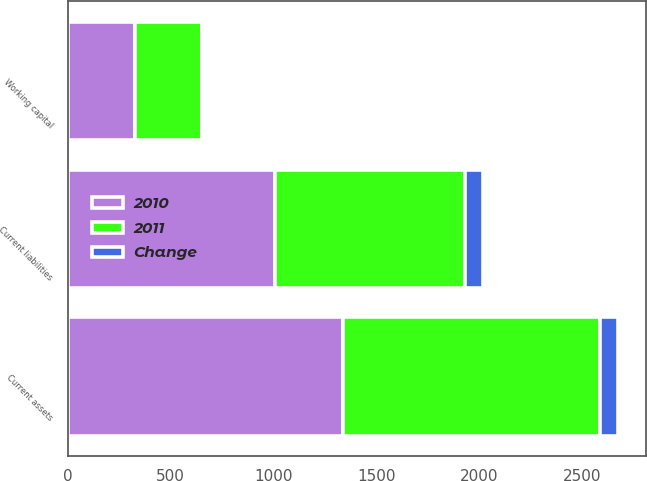Convert chart. <chart><loc_0><loc_0><loc_500><loc_500><stacked_bar_chart><ecel><fcel>Current assets<fcel>Current liabilities<fcel>Working capital<nl><fcel>2010<fcel>1338.1<fcel>1008.8<fcel>329.3<nl><fcel>2011<fcel>1247.8<fcel>921.8<fcel>326<nl><fcel>Change<fcel>90.3<fcel>87<fcel>3.3<nl></chart> 